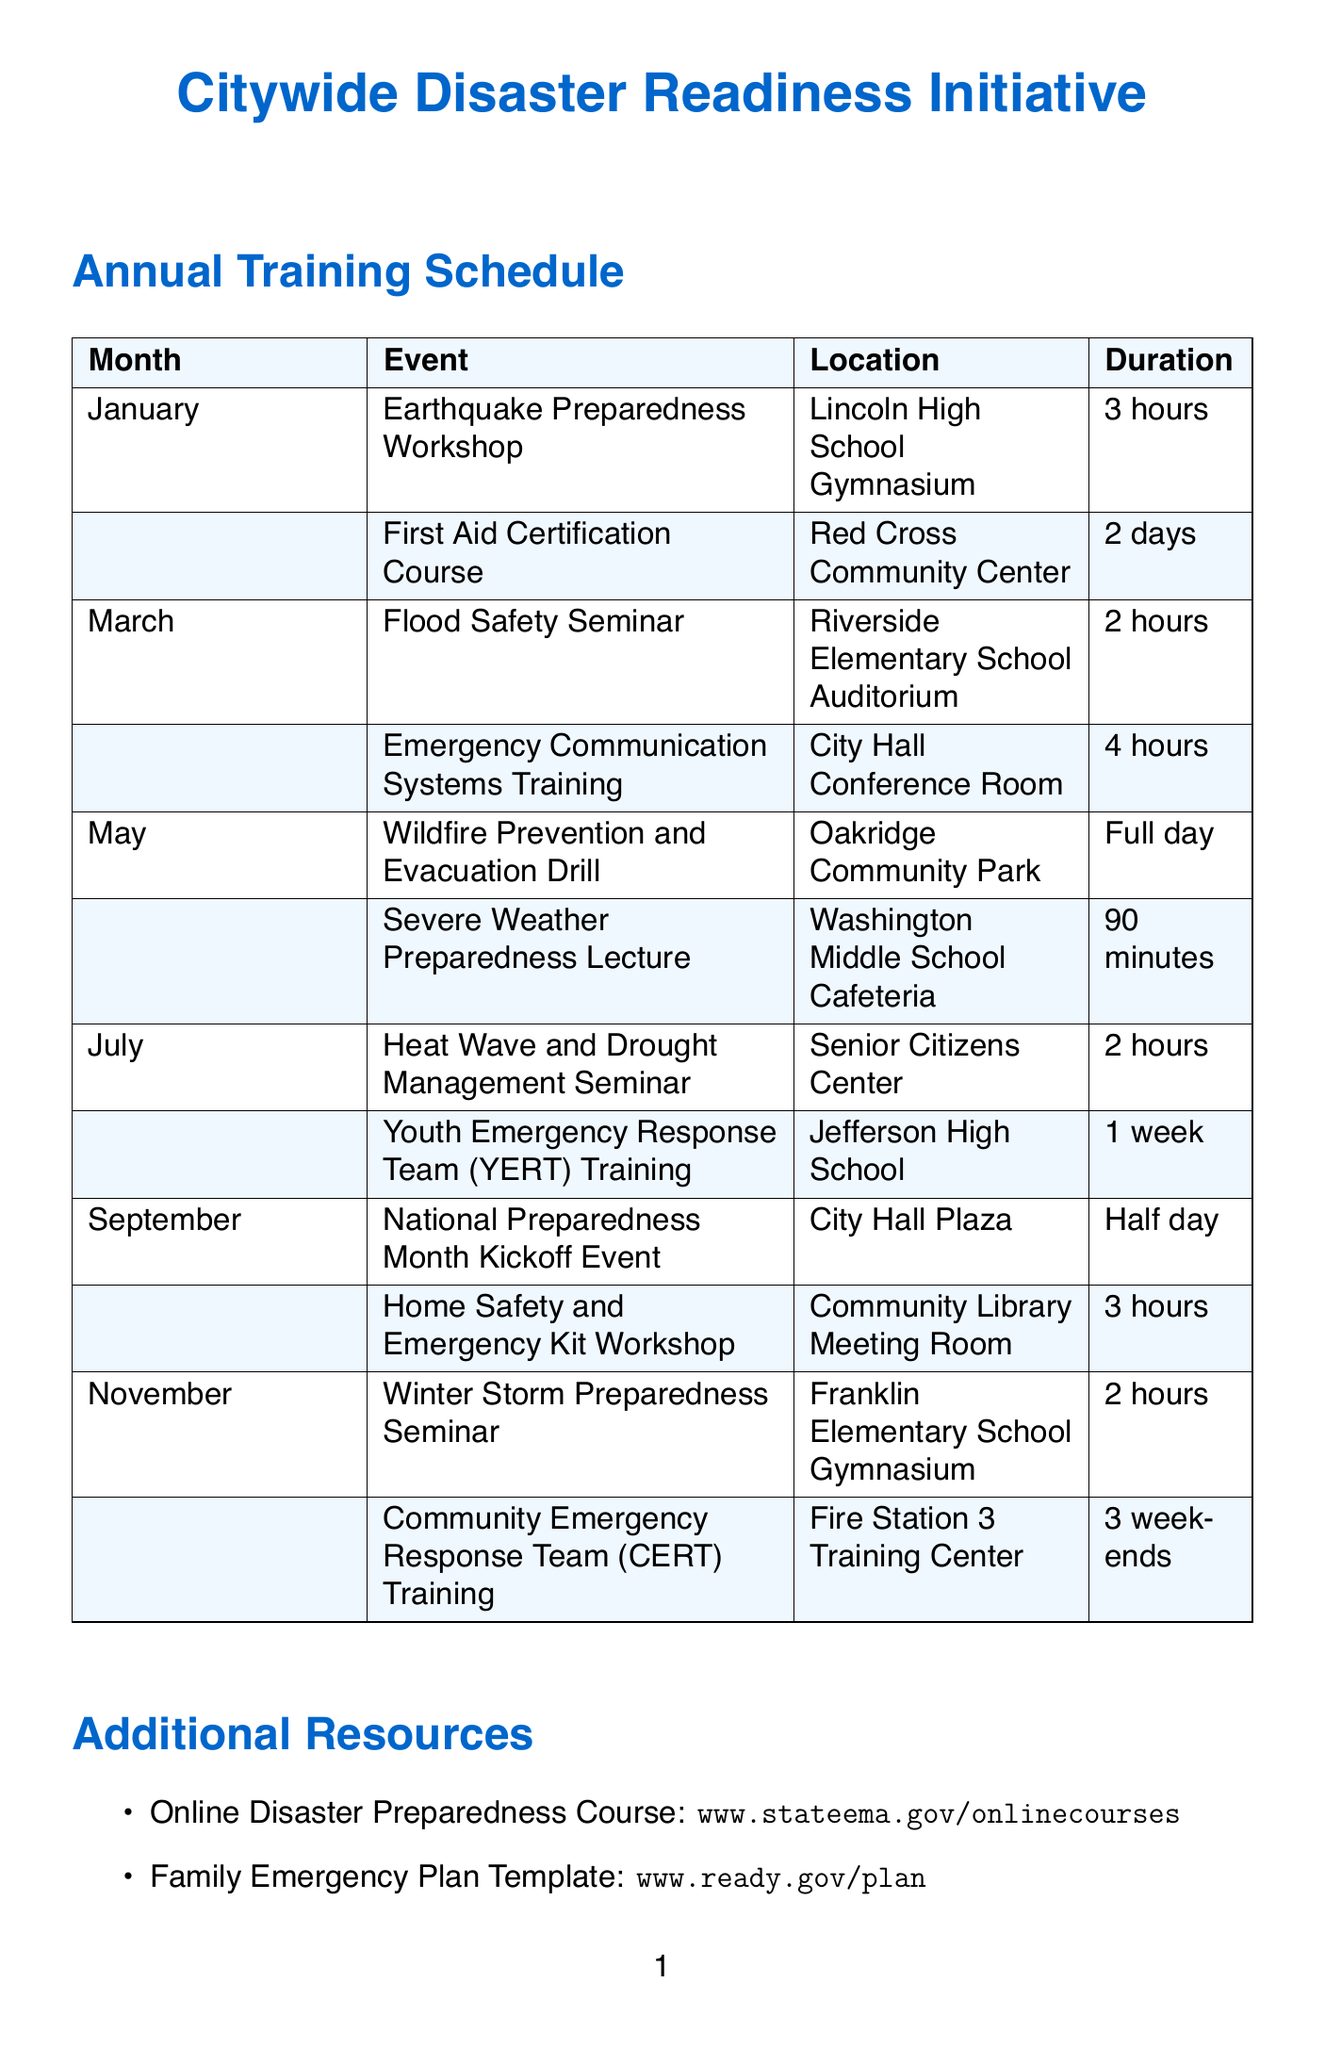what is the name of the initiative? The initiative is titled "Citywide Disaster Readiness Initiative."
Answer: Citywide Disaster Readiness Initiative who is the trainer for the Earthquake Preparedness Workshop? The trainer for this workshop is Dr. Susan Chen, a Seismologist.
Answer: Dr. Susan Chen, Seismologist how many hours is the Flood Safety Seminar? The duration of the Flood Safety Seminar is 2 hours.
Answer: 2 hours which month has a full day event? The month of May has a full day event, specifically the Wildfire Prevention and Evacuation Drill.
Answer: May how many weekends does the CERT Training span? The Community Emergency Response Team (CERT) Training spans over 3 weekends.
Answer: 3 weekends which community center is hosting the First Aid Certification Course? The First Aid Certification Course is being hosted at the Red Cross Community Center.
Answer: Red Cross Community Center who is the coordinator of the program? The program coordinator is Jessica Martinez.
Answer: Jessica Martinez what is the location for the Youth Emergency Response Team Training? The Youth Emergency Response Team (YERT) Training is located at Jefferson High School.
Answer: Jefferson High School 